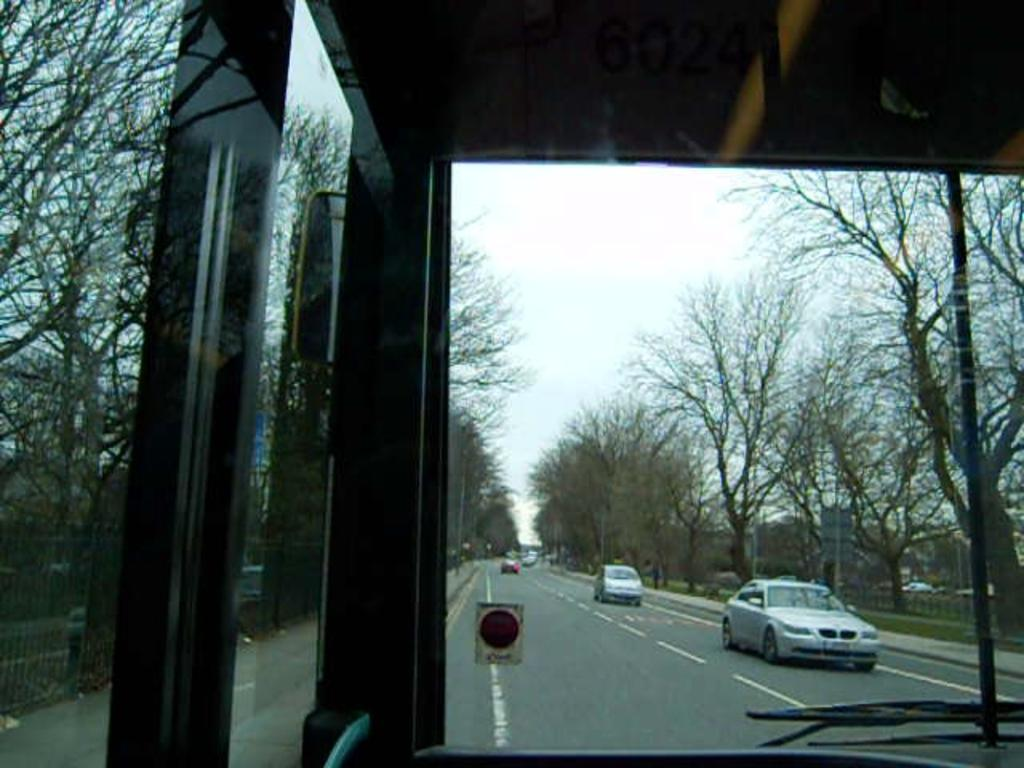What is the perspective of the image? The image is a view from a bus. What type of vehicles can be seen on the road in the image? There are cars riding on the road in the image. What natural elements are present beside the road in the image? There are trees beside the road in the image. What type of haircut is the tree getting in the image? There is no haircut being given to the tree in the image; it is a natural element beside the road. 